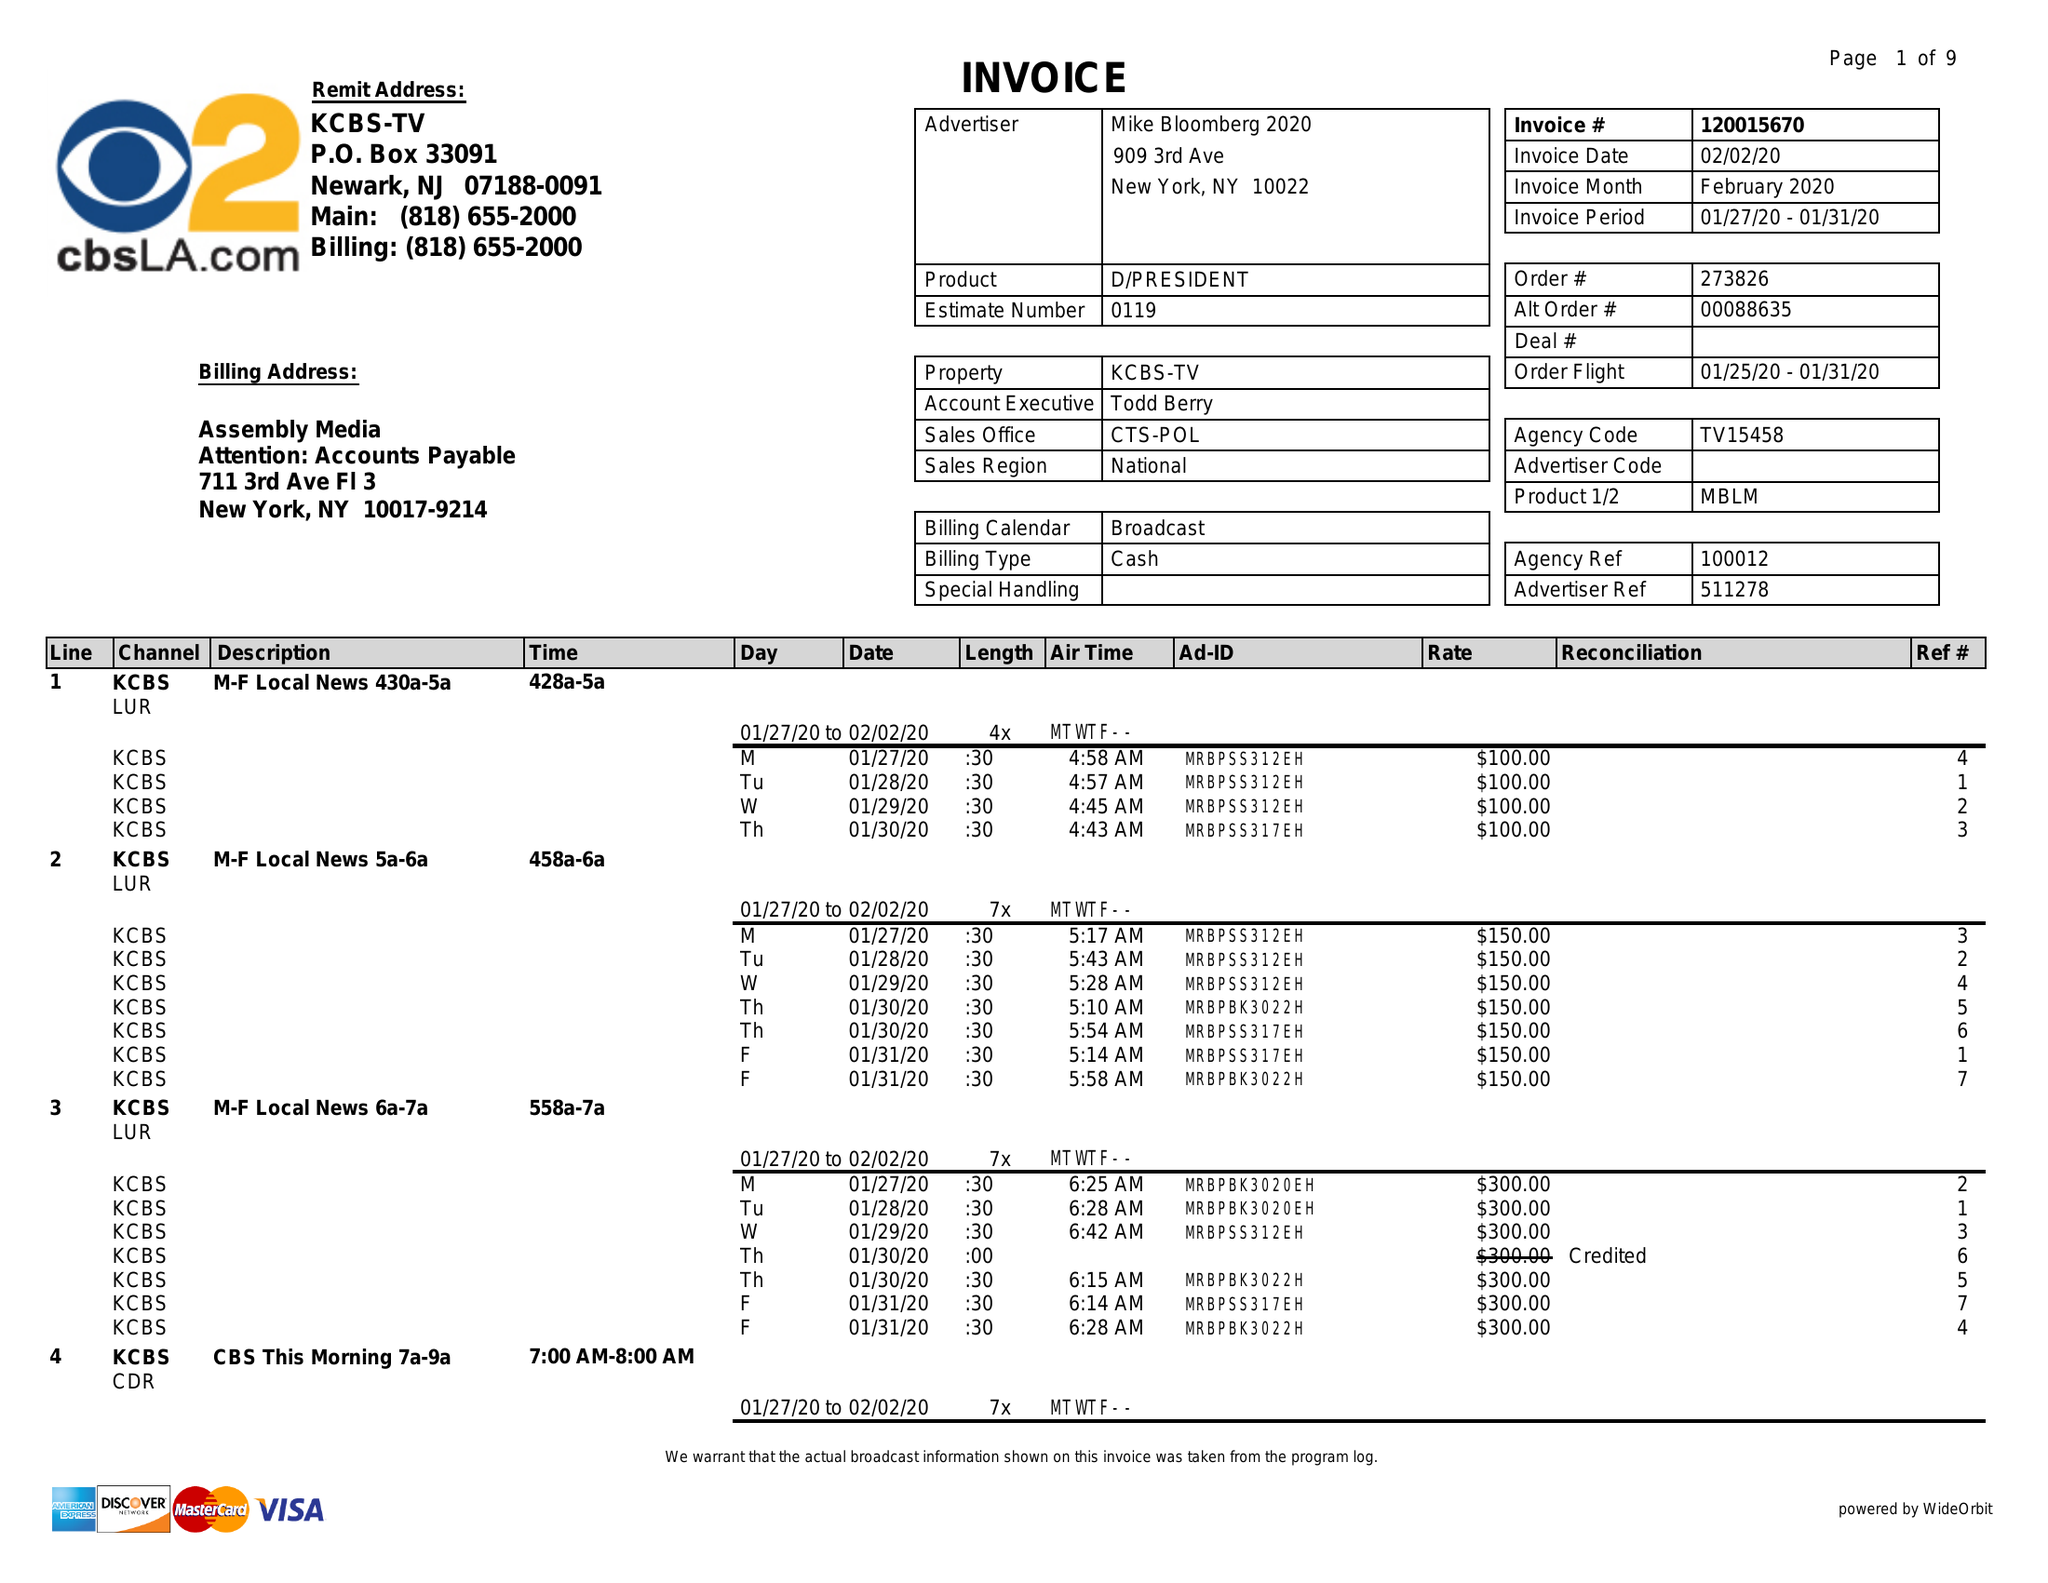What is the value for the flight_from?
Answer the question using a single word or phrase. 01/25/20 